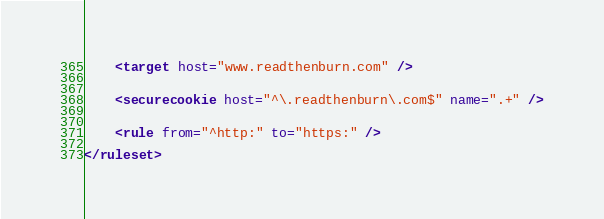Convert code to text. <code><loc_0><loc_0><loc_500><loc_500><_XML_>	<target host="www.readthenburn.com" />


	<securecookie host="^\.readthenburn\.com$" name=".+" />


	<rule from="^http:" to="https:" />

</ruleset>
</code> 